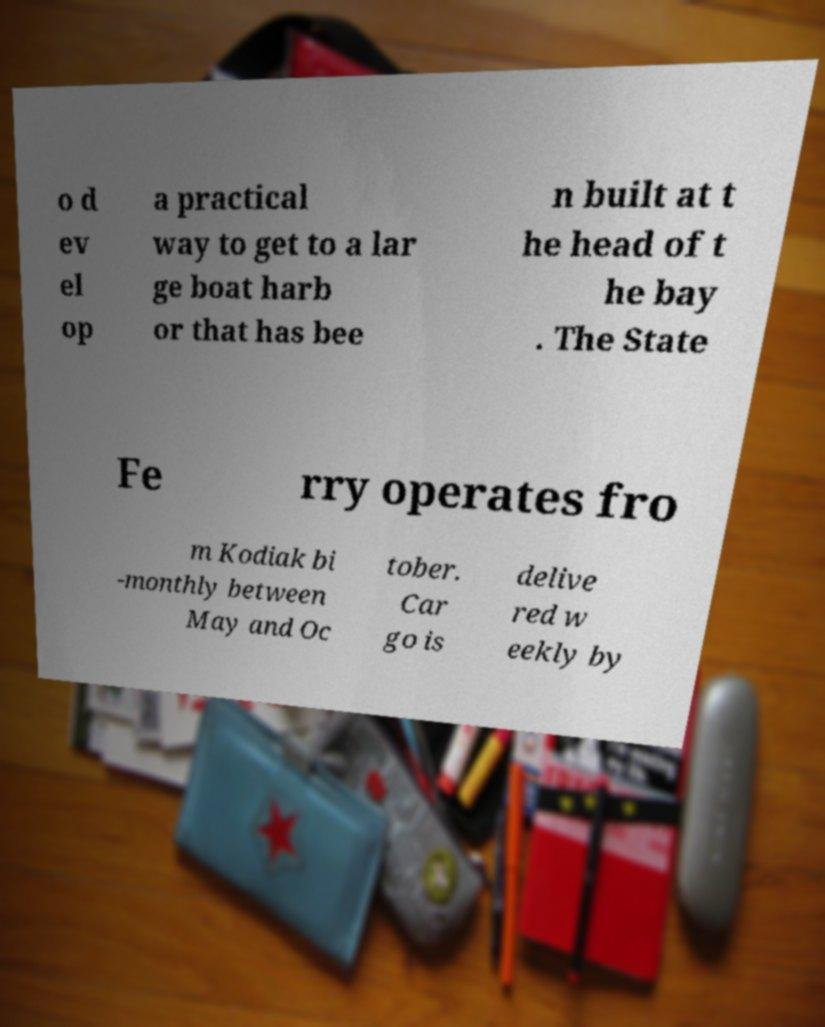Please read and relay the text visible in this image. What does it say? o d ev el op a practical way to get to a lar ge boat harb or that has bee n built at t he head of t he bay . The State Fe rry operates fro m Kodiak bi -monthly between May and Oc tober. Car go is delive red w eekly by 